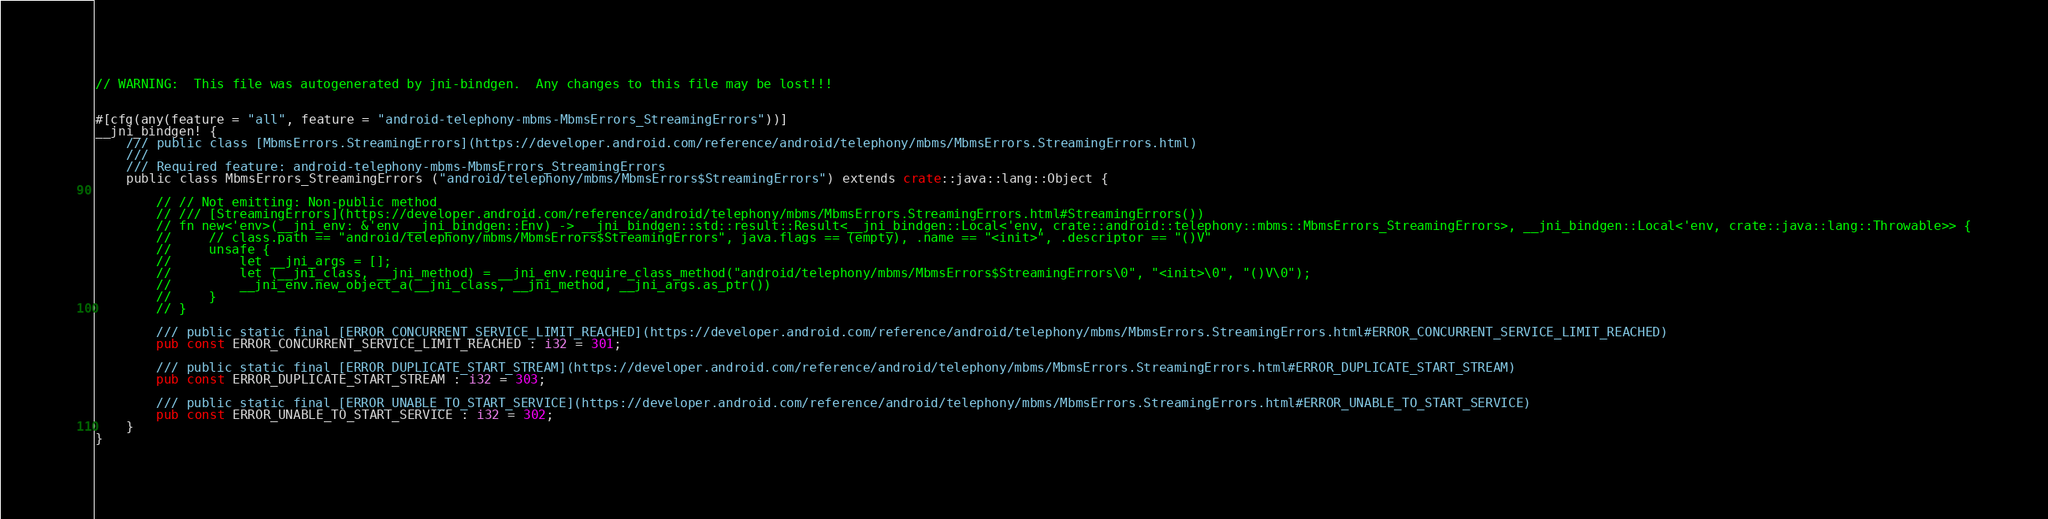Convert code to text. <code><loc_0><loc_0><loc_500><loc_500><_Rust_>// WARNING:  This file was autogenerated by jni-bindgen.  Any changes to this file may be lost!!!


#[cfg(any(feature = "all", feature = "android-telephony-mbms-MbmsErrors_StreamingErrors"))]
__jni_bindgen! {
    /// public class [MbmsErrors.StreamingErrors](https://developer.android.com/reference/android/telephony/mbms/MbmsErrors.StreamingErrors.html)
    ///
    /// Required feature: android-telephony-mbms-MbmsErrors_StreamingErrors
    public class MbmsErrors_StreamingErrors ("android/telephony/mbms/MbmsErrors$StreamingErrors") extends crate::java::lang::Object {

        // // Not emitting: Non-public method
        // /// [StreamingErrors](https://developer.android.com/reference/android/telephony/mbms/MbmsErrors.StreamingErrors.html#StreamingErrors())
        // fn new<'env>(__jni_env: &'env __jni_bindgen::Env) -> __jni_bindgen::std::result::Result<__jni_bindgen::Local<'env, crate::android::telephony::mbms::MbmsErrors_StreamingErrors>, __jni_bindgen::Local<'env, crate::java::lang::Throwable>> {
        //     // class.path == "android/telephony/mbms/MbmsErrors$StreamingErrors", java.flags == (empty), .name == "<init>", .descriptor == "()V"
        //     unsafe {
        //         let __jni_args = [];
        //         let (__jni_class, __jni_method) = __jni_env.require_class_method("android/telephony/mbms/MbmsErrors$StreamingErrors\0", "<init>\0", "()V\0");
        //         __jni_env.new_object_a(__jni_class, __jni_method, __jni_args.as_ptr())
        //     }
        // }

        /// public static final [ERROR_CONCURRENT_SERVICE_LIMIT_REACHED](https://developer.android.com/reference/android/telephony/mbms/MbmsErrors.StreamingErrors.html#ERROR_CONCURRENT_SERVICE_LIMIT_REACHED)
        pub const ERROR_CONCURRENT_SERVICE_LIMIT_REACHED : i32 = 301;

        /// public static final [ERROR_DUPLICATE_START_STREAM](https://developer.android.com/reference/android/telephony/mbms/MbmsErrors.StreamingErrors.html#ERROR_DUPLICATE_START_STREAM)
        pub const ERROR_DUPLICATE_START_STREAM : i32 = 303;

        /// public static final [ERROR_UNABLE_TO_START_SERVICE](https://developer.android.com/reference/android/telephony/mbms/MbmsErrors.StreamingErrors.html#ERROR_UNABLE_TO_START_SERVICE)
        pub const ERROR_UNABLE_TO_START_SERVICE : i32 = 302;
    }
}
</code> 